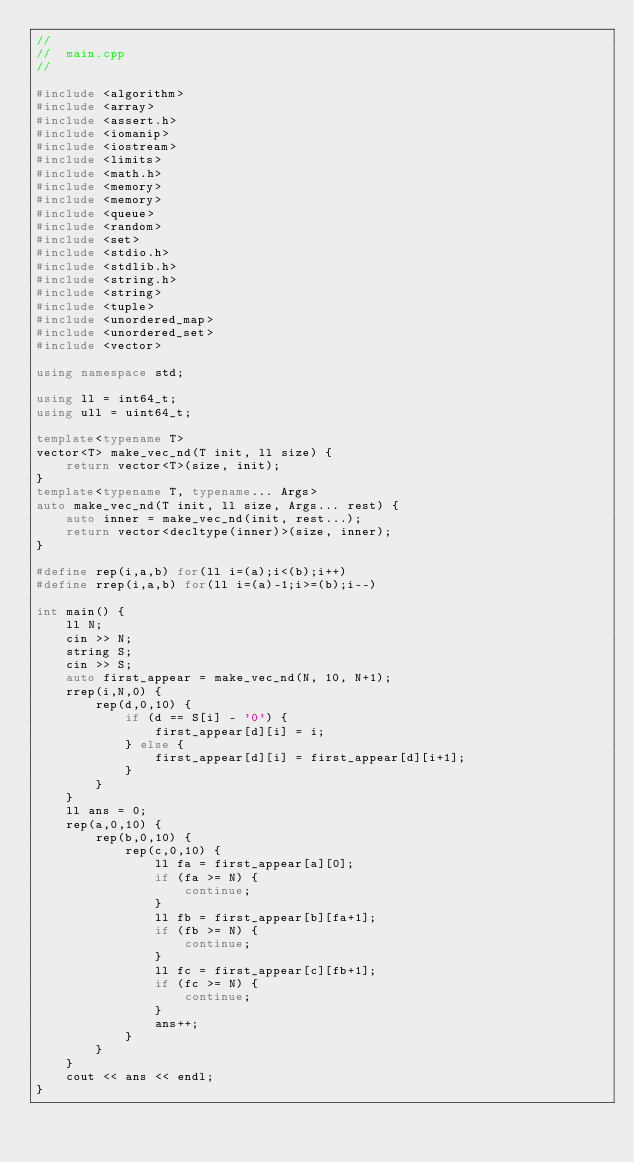<code> <loc_0><loc_0><loc_500><loc_500><_C++_>//
//  main.cpp
//

#include <algorithm>
#include <array>
#include <assert.h>
#include <iomanip>
#include <iostream>
#include <limits>
#include <math.h>
#include <memory>
#include <memory>
#include <queue>
#include <random>
#include <set>
#include <stdio.h>
#include <stdlib.h>
#include <string.h>
#include <string>
#include <tuple>
#include <unordered_map>
#include <unordered_set>
#include <vector>

using namespace std;

using ll = int64_t;
using ull = uint64_t;

template<typename T>
vector<T> make_vec_nd(T init, ll size) {
    return vector<T>(size, init);
}
template<typename T, typename... Args>
auto make_vec_nd(T init, ll size, Args... rest) {
    auto inner = make_vec_nd(init, rest...);
    return vector<decltype(inner)>(size, inner);
}

#define rep(i,a,b) for(ll i=(a);i<(b);i++)
#define rrep(i,a,b) for(ll i=(a)-1;i>=(b);i--)

int main() {
    ll N;
    cin >> N;
    string S;
    cin >> S;
    auto first_appear = make_vec_nd(N, 10, N+1);
    rrep(i,N,0) {
        rep(d,0,10) {
            if (d == S[i] - '0') {
                first_appear[d][i] = i;
            } else {
                first_appear[d][i] = first_appear[d][i+1];
            }
        }
    }
    ll ans = 0;
    rep(a,0,10) {
        rep(b,0,10) {
            rep(c,0,10) {
                ll fa = first_appear[a][0];
                if (fa >= N) {
                    continue;
                }
                ll fb = first_appear[b][fa+1];
                if (fb >= N) {
                    continue;
                }
                ll fc = first_appear[c][fb+1];
                if (fc >= N) {
                    continue;
                }
                ans++;
            }
        }
    }
    cout << ans << endl;
}

</code> 